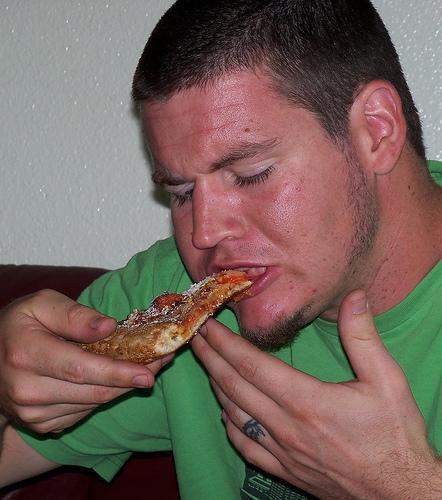How many people are in the picture?
Give a very brief answer. 1. 